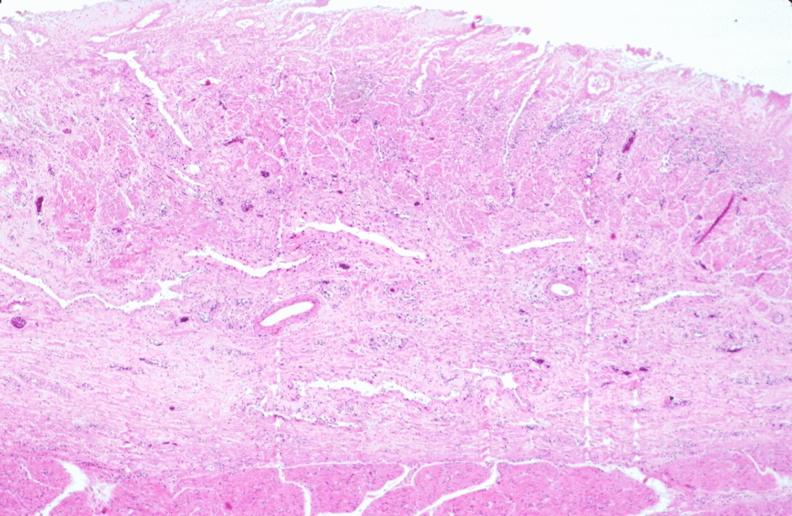where is this from?
Answer the question using a single word or phrase. Gastrointestinal system 